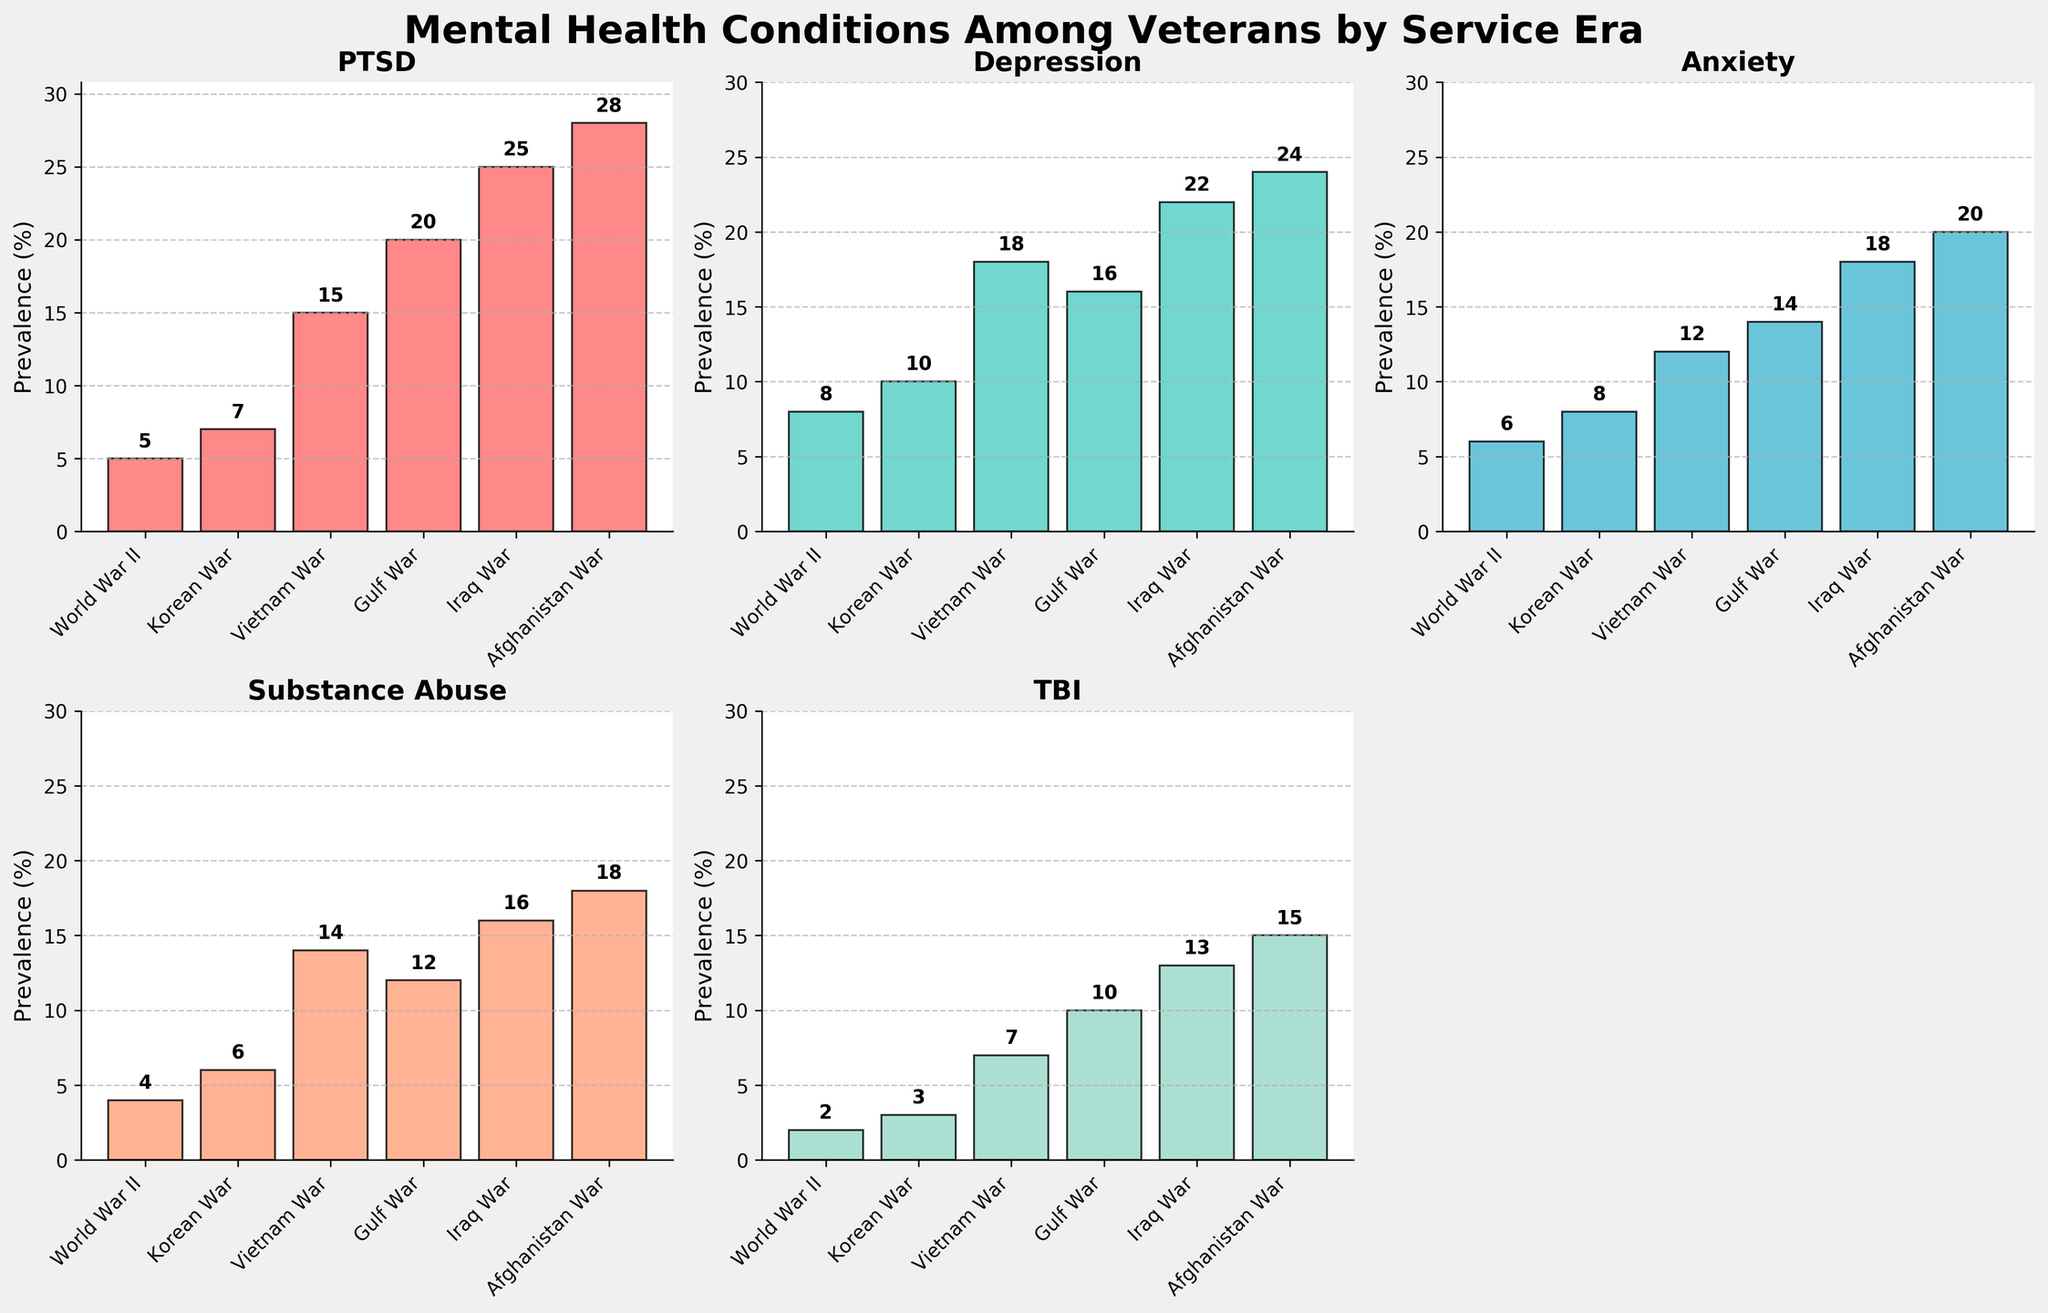What mental health condition is most prevalent among veterans of the Afghanistan War? By scanning the bar heights across the plots, observe that PTSD has the highest bar in the Afghanistan War subplot.
Answer: PTSD Which service era has the highest reported prevalence of TBI? Look for the tallest bar in the TBI subplot. All service eras are labeled clearly, and the tallest bar corresponds to the Afghanistan War.
Answer: Afghanistan War How does the prevalence of Depression compare between the Vietnam War and Gulf War? By comparing the bar heights in the Depression subplot, we see the Vietnam War bar is slightly higher than the Gulf War bar.
Answer: Vietnam War is higher What's the combined prevalence of Substance Abuse among Vietnam War and Gulf War veterans? Add the prevalence values from the Substance Abuse subplot: for Vietnam War (14%) and Gulf War (12%). So, 14 + 12 = 26.
Answer: 26% In which mental health condition do veterans of the Iraq and Afghanistan Wars exhibit the greatest difference? Compare the heights of the bars for each condition between Iraq and Afghanistan subplots, and note the greatest difference is in TBI (13 for Iraq and 15 for Afghanistan).
Answer: TBI What trend can be observed in the prevalence of PTSD across different service eras? Review the bars in the PTSD subplot from left to right; there is a distinct increasing trend from World War II to Afghanistan War.
Answer: Increasing trend What is the average prevalence of Anxiety among veterans from the Korean War, Vietnam War, and Gulf War? Sum the prevalence values from the Anxiety subplot for these wars (8% for Korean War, 12% for Vietnam War, 14% for Gulf War) and then divide by 3: (8 + 12 + 14) / 3 = 11.33.
Answer: 11.33% Which mental health condition has the most similar prevalence values across all service eras? By viewing all plots visually, Substance Abuse bars appear most similar in height across service eras.
Answer: Substance Abuse How does the prevalence of PTSD compare between World War II and Iraq War veterans? Compare the bar heights in the PTSD subplot for World War II and Iraq War. The PTSD prevalence is significantly higher for Iraq War (25%) than World War II (5%).
Answer: Iraq War is higher What is the total prevalence of Depression in veterans from all service eras combined? Sum the prevalence values from the Depression subplot: 8 (World War II) + 10 (Korean War) + 18 (Vietnam War) + 16 (Gulf War) + 22 (Iraq War) + 24 (Afghanistan War) = 98.
Answer: 98% 